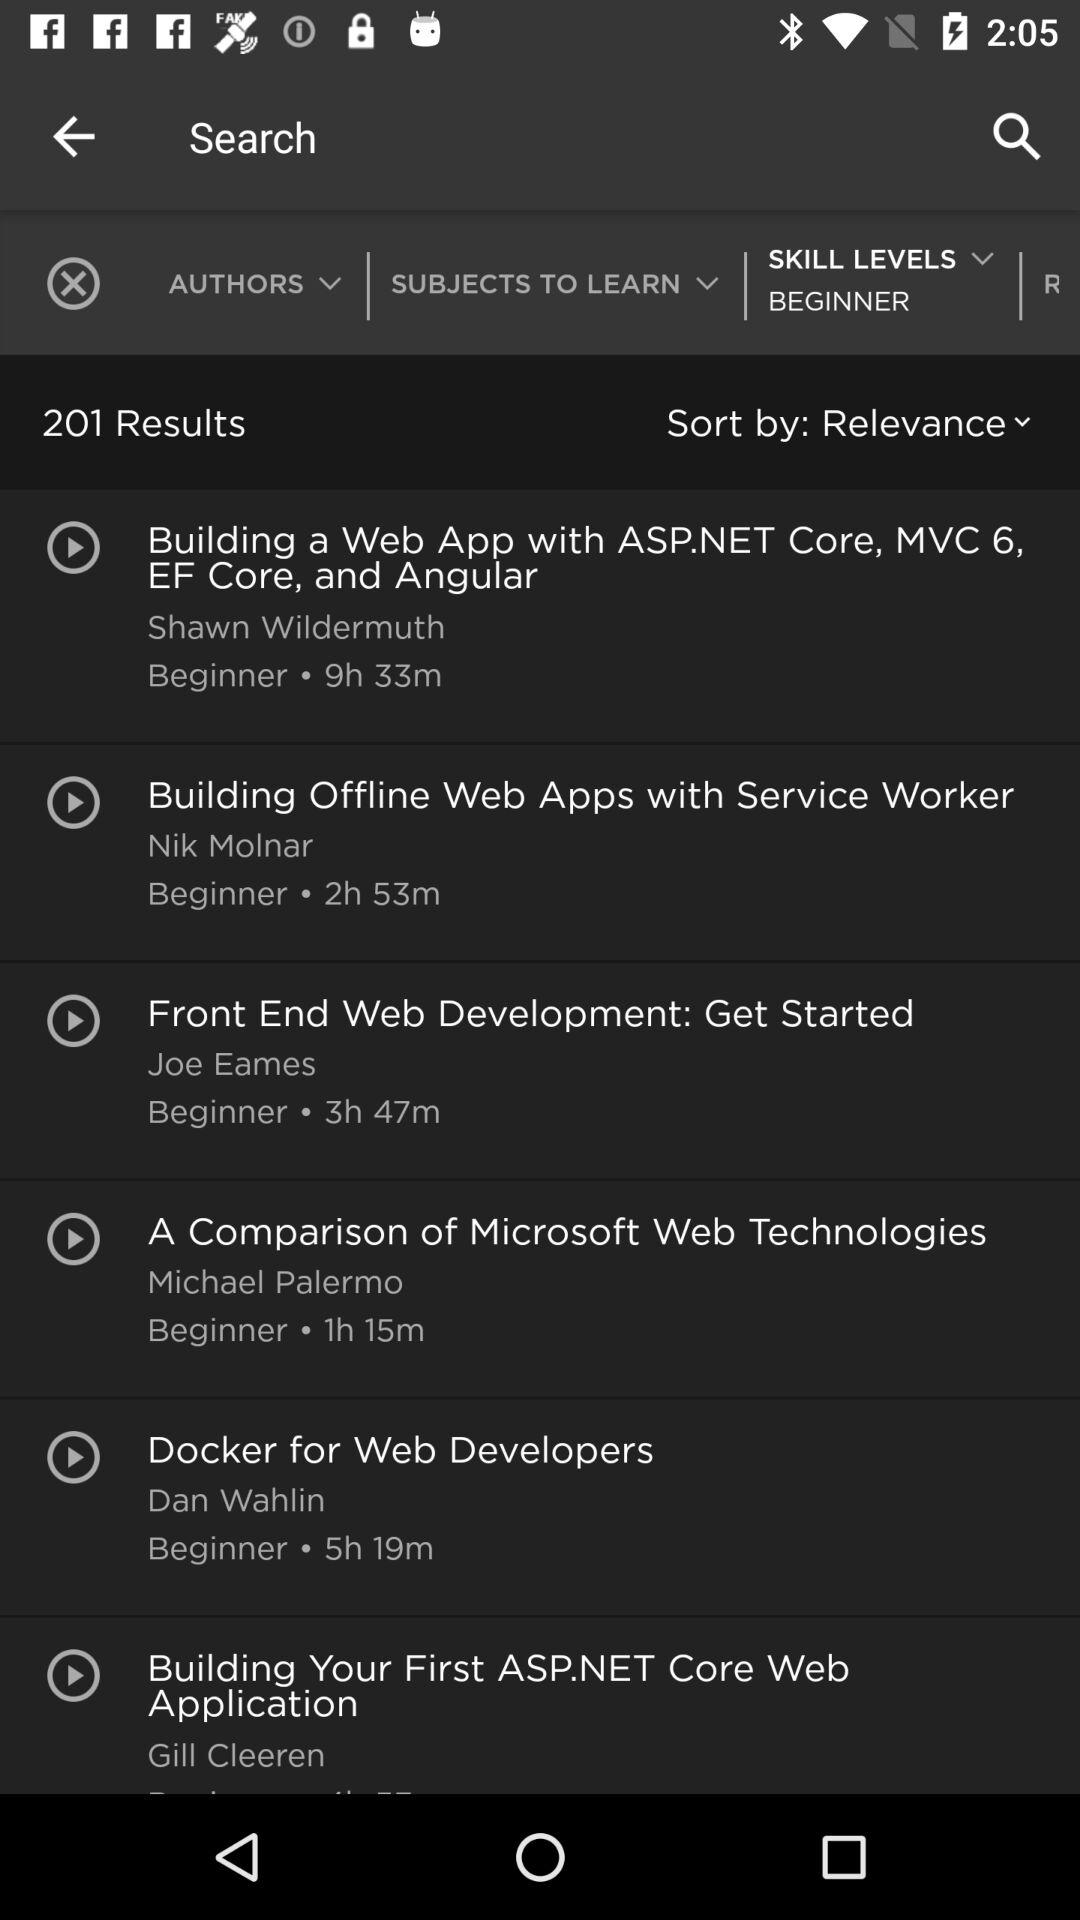Who is the author of the topic "A Comparison of Microsoft Web Technologies"? The author of the topic "A Comparison of Microsoft Web Technologies" is Michael Palermo. 